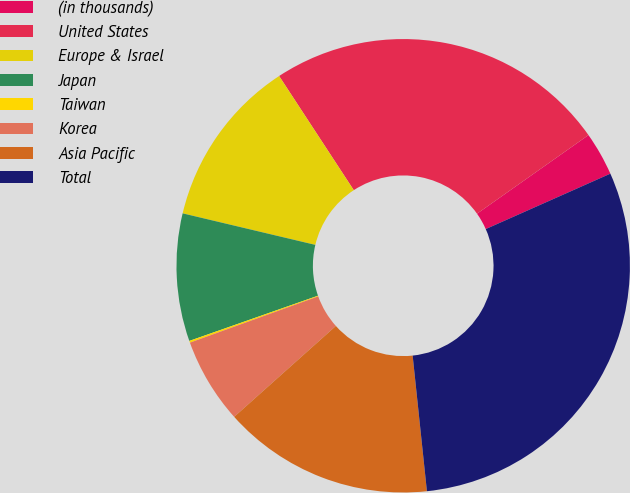Convert chart. <chart><loc_0><loc_0><loc_500><loc_500><pie_chart><fcel>(in thousands)<fcel>United States<fcel>Europe & Israel<fcel>Japan<fcel>Taiwan<fcel>Korea<fcel>Asia Pacific<fcel>Total<nl><fcel>3.12%<fcel>24.44%<fcel>12.07%<fcel>9.09%<fcel>0.13%<fcel>6.1%<fcel>15.06%<fcel>29.99%<nl></chart> 